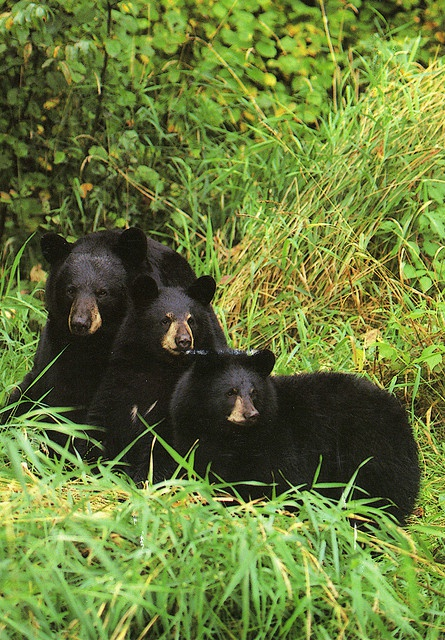Describe the objects in this image and their specific colors. I can see bear in green, black, gray, and darkgreen tones, bear in green, black, gray, and darkgreen tones, and bear in green, black, gray, and darkgreen tones in this image. 